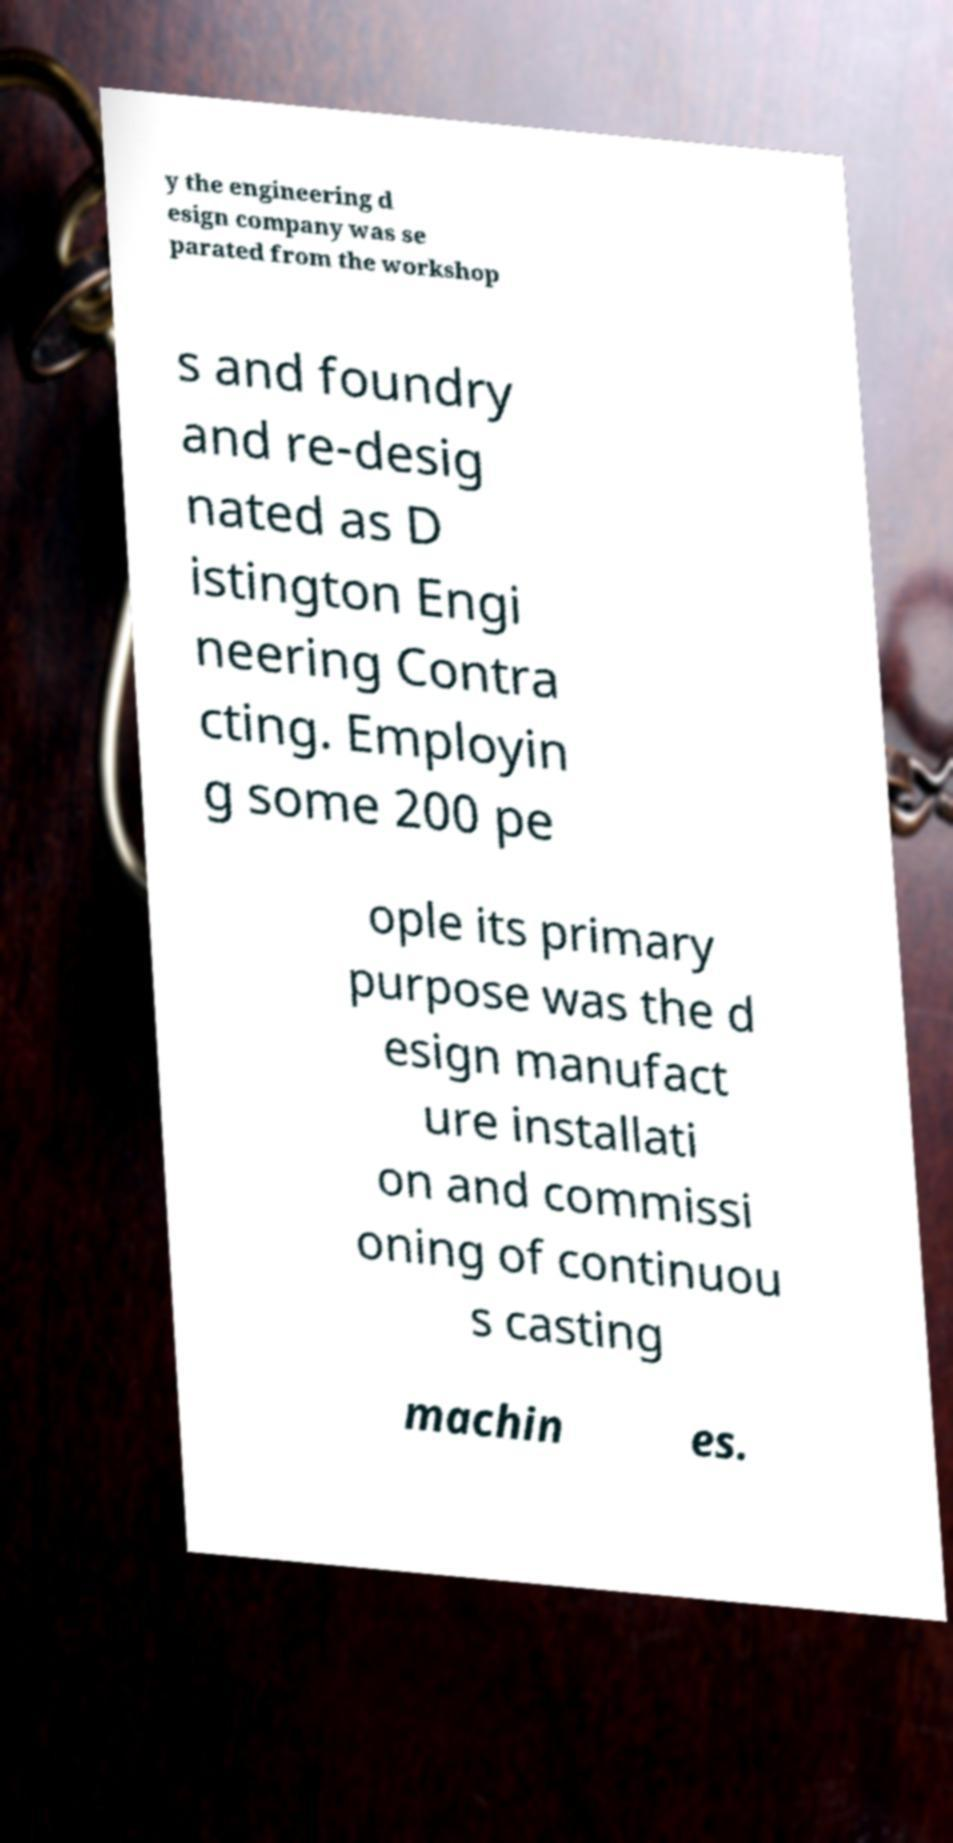Can you read and provide the text displayed in the image?This photo seems to have some interesting text. Can you extract and type it out for me? y the engineering d esign company was se parated from the workshop s and foundry and re-desig nated as D istington Engi neering Contra cting. Employin g some 200 pe ople its primary purpose was the d esign manufact ure installati on and commissi oning of continuou s casting machin es. 